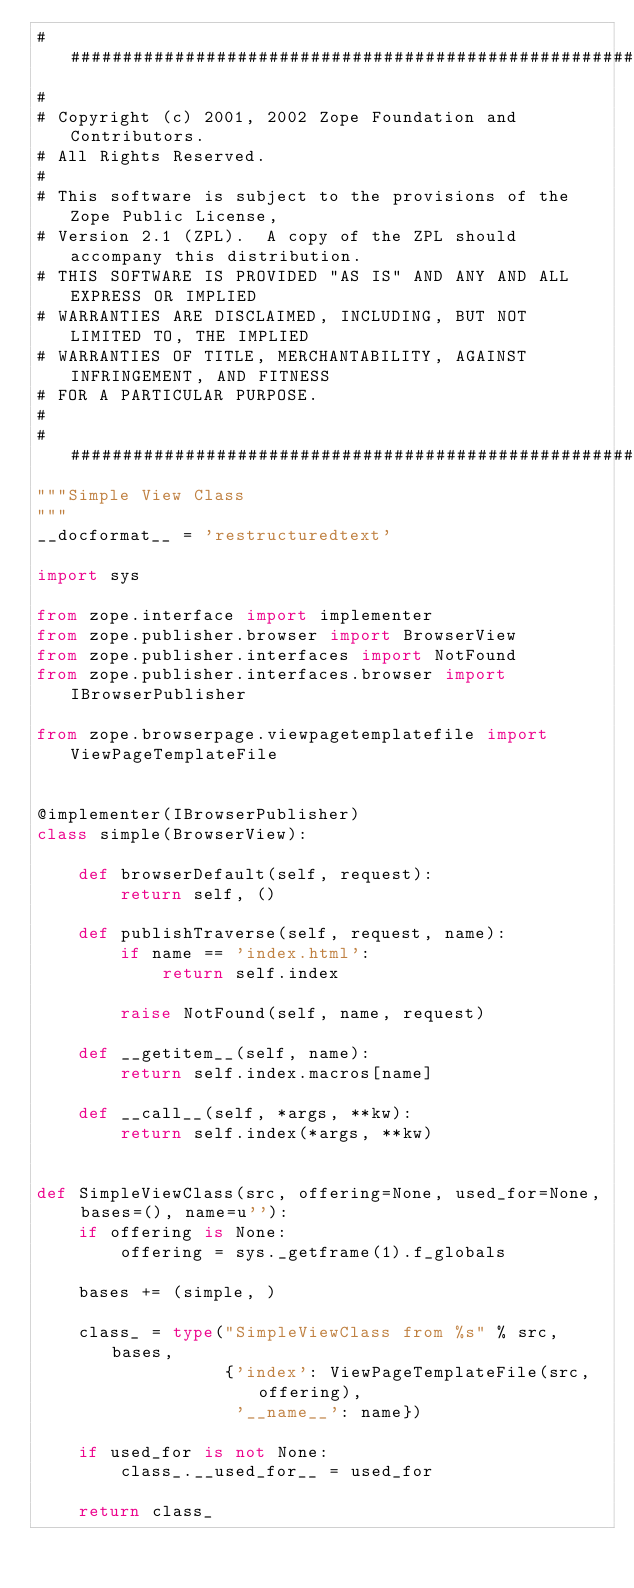<code> <loc_0><loc_0><loc_500><loc_500><_Python_>##############################################################################
#
# Copyright (c) 2001, 2002 Zope Foundation and Contributors.
# All Rights Reserved.
#
# This software is subject to the provisions of the Zope Public License,
# Version 2.1 (ZPL).  A copy of the ZPL should accompany this distribution.
# THIS SOFTWARE IS PROVIDED "AS IS" AND ANY AND ALL EXPRESS OR IMPLIED
# WARRANTIES ARE DISCLAIMED, INCLUDING, BUT NOT LIMITED TO, THE IMPLIED
# WARRANTIES OF TITLE, MERCHANTABILITY, AGAINST INFRINGEMENT, AND FITNESS
# FOR A PARTICULAR PURPOSE.
#
##############################################################################
"""Simple View Class
"""
__docformat__ = 'restructuredtext'

import sys

from zope.interface import implementer
from zope.publisher.browser import BrowserView
from zope.publisher.interfaces import NotFound
from zope.publisher.interfaces.browser import IBrowserPublisher

from zope.browserpage.viewpagetemplatefile import ViewPageTemplateFile


@implementer(IBrowserPublisher)
class simple(BrowserView):

    def browserDefault(self, request):
        return self, ()

    def publishTraverse(self, request, name):
        if name == 'index.html':
            return self.index

        raise NotFound(self, name, request)

    def __getitem__(self, name):
        return self.index.macros[name]

    def __call__(self, *args, **kw):
        return self.index(*args, **kw)


def SimpleViewClass(src, offering=None, used_for=None, bases=(), name=u''):
    if offering is None:
        offering = sys._getframe(1).f_globals

    bases += (simple, )

    class_ = type("SimpleViewClass from %s" % src, bases,
                  {'index': ViewPageTemplateFile(src, offering),
                   '__name__': name})

    if used_for is not None:
        class_.__used_for__ = used_for

    return class_
</code> 